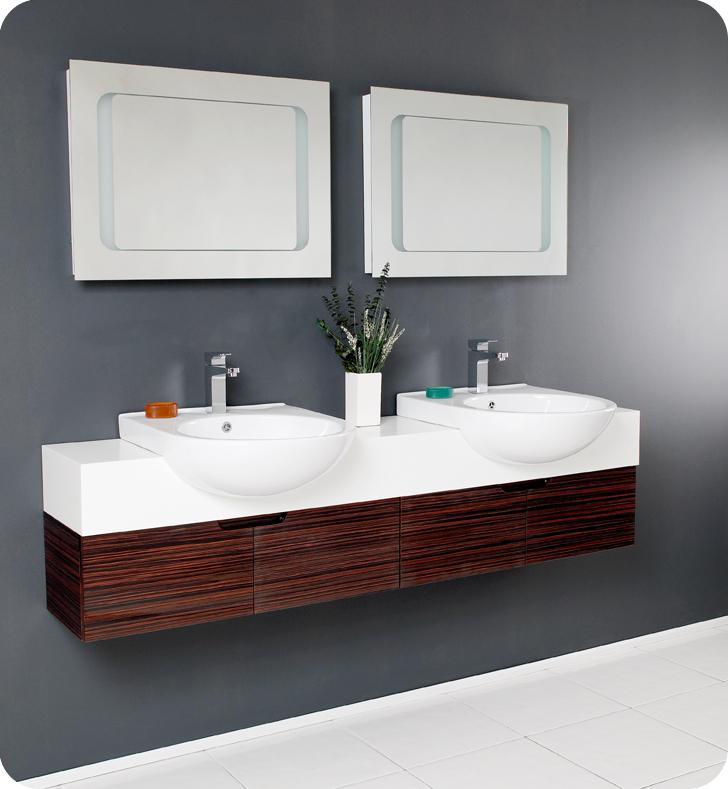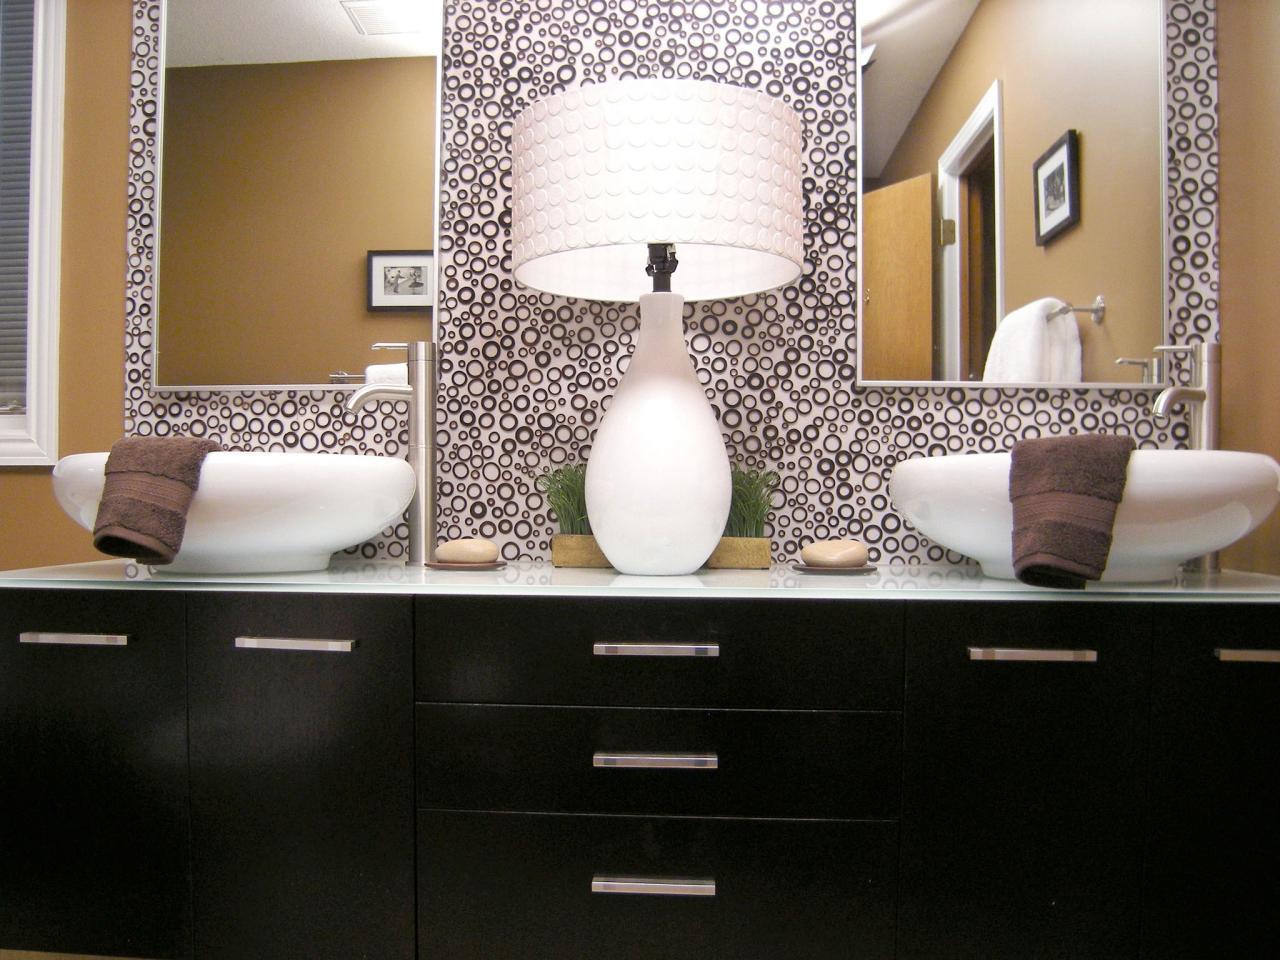The first image is the image on the left, the second image is the image on the right. For the images displayed, is the sentence "The vanity in the right-hand image features a pair of squarish white basins sitting on top." factually correct? Answer yes or no. No. The first image is the image on the left, the second image is the image on the right. Assess this claim about the two images: "In one image, one large mirror is positioned over a long open wooden vanity on feet with two matching white sinks.". Correct or not? Answer yes or no. No. 